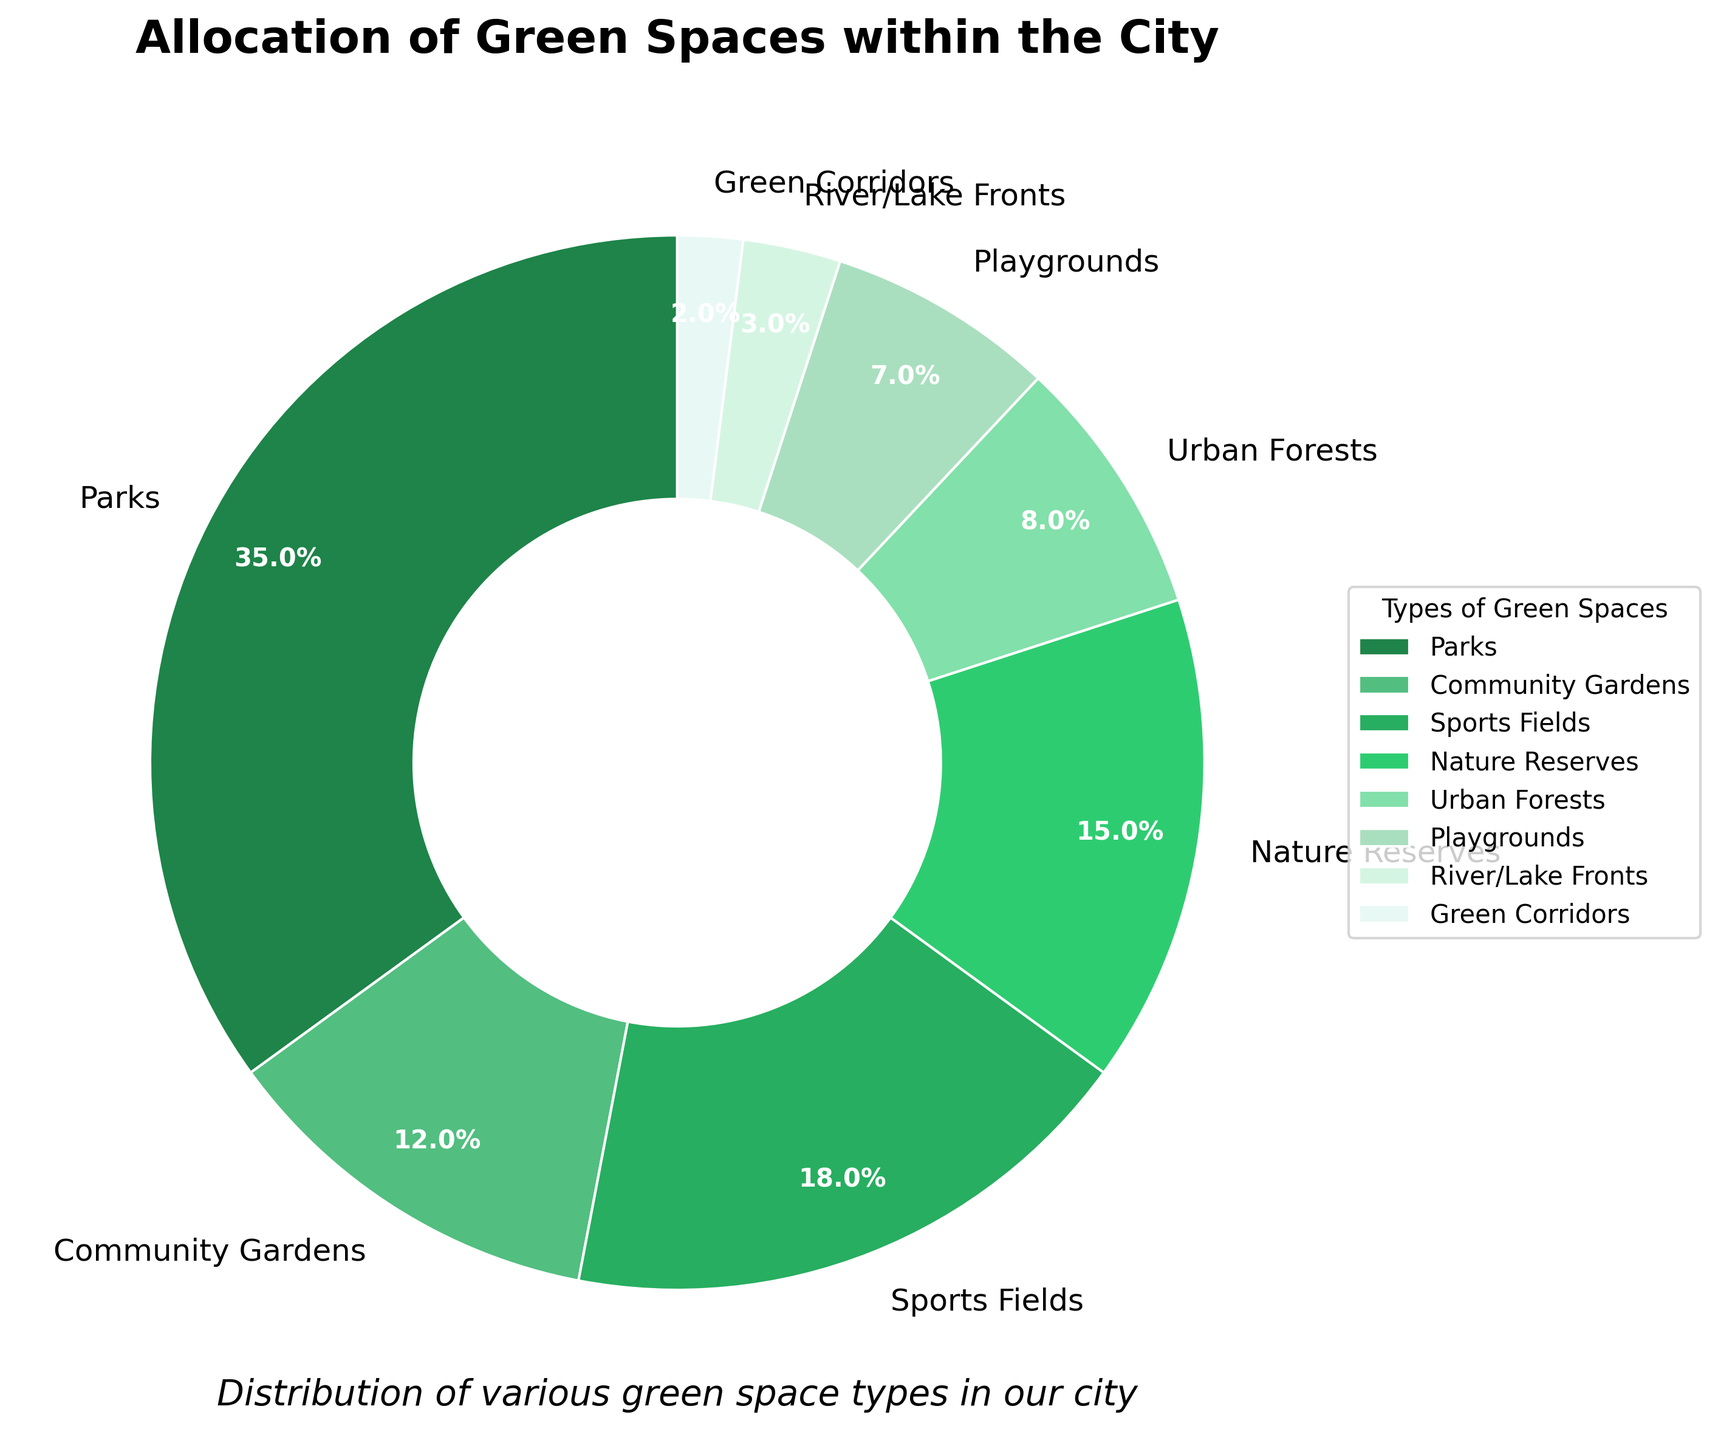What is the most common type of green space in the city? The most common type of green space in the pie chart is the section with the largest percentage. According to the data, parks make up the largest portion at 35%.
Answer: Parks Which green space type occupies the smallest area within the city? By observing the smallest slice in the pie chart, we find that green corridors occupy the smallest area, amounting to only 2%.
Answer: Green Corridors How much more percentage do parks occupy compared to community gardens? To find the difference, subtract the percentage of community gardens from that of parks: 35% - 12% = 23%.
Answer: 23% Which types of green spaces together make up more than half of the city's green space allocation? We need the sum of proportions. Parks (35%) and sports fields (18%) alone already contribute more than half (35% + 18% = 53%).
Answer: Parks and Sports Fields What is the combined percentage of all the green spaces other than parks? Subtract the percentage of parks from the total: 100% - 35% = 65%.
Answer: 65% Compare the visual attributes of parks and urban forests in terms of their size on the pie chart. Parks have the largest slice on the pie chart, visually taking up more space, while urban forests have a smaller slice that visually occupies less area. Parks are more dominant.
Answer: Parks are larger Is the percentage of sports fields closer to community gardens' or nature reserves' percentage? Sports Fields are at 18%. Community Gardens are at 12%, and Nature Reserves are at 15%. The difference with Nature Reserves is smaller (18% - 15% = 3%) than with Community Gardens (18% - 12% = 6%).
Answer: Nature Reserves What proportion of the total green space is dedicated to sports and nature reserves combined? Add the percentages: 18% (sports fields) + 15% (nature reserves) = 33%.
Answer: 33% Which type of green space takes up nearly a tenth of the city's total green space allocation? Approximately one-tenth of 100% is 10%. Community Gardens take up 12% and are the closest to this value.
Answer: Community Gardens What is the difference in percentage between the second most and the second least common types of green spaces? The second most common type is sports fields (18%), and the second least is playgrounds (7%). The difference: 18% - 7% = 11%.
Answer: 11% 